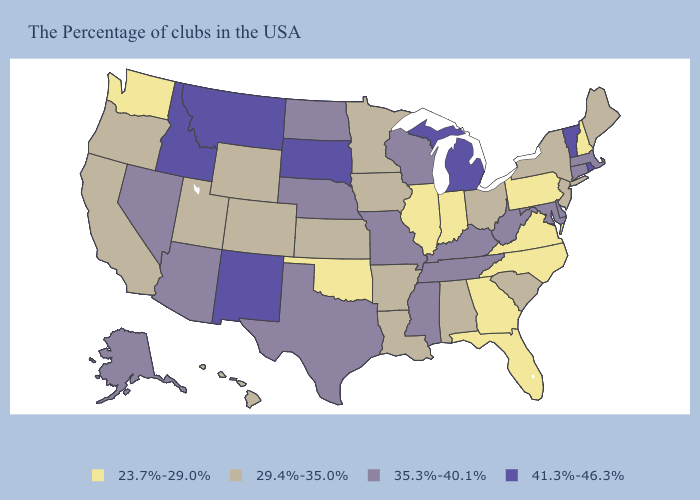Name the states that have a value in the range 35.3%-40.1%?
Concise answer only. Massachusetts, Connecticut, Delaware, Maryland, West Virginia, Kentucky, Tennessee, Wisconsin, Mississippi, Missouri, Nebraska, Texas, North Dakota, Arizona, Nevada, Alaska. What is the highest value in the USA?
Give a very brief answer. 41.3%-46.3%. Among the states that border Michigan , which have the lowest value?
Answer briefly. Indiana. Among the states that border Utah , which have the lowest value?
Answer briefly. Wyoming, Colorado. What is the lowest value in the MidWest?
Answer briefly. 23.7%-29.0%. What is the lowest value in the West?
Concise answer only. 23.7%-29.0%. What is the value of Nevada?
Write a very short answer. 35.3%-40.1%. What is the lowest value in the USA?
Answer briefly. 23.7%-29.0%. Among the states that border Arizona , does Nevada have the lowest value?
Quick response, please. No. How many symbols are there in the legend?
Short answer required. 4. What is the highest value in states that border Texas?
Short answer required. 41.3%-46.3%. Which states have the highest value in the USA?
Write a very short answer. Rhode Island, Vermont, Michigan, South Dakota, New Mexico, Montana, Idaho. Name the states that have a value in the range 23.7%-29.0%?
Keep it brief. New Hampshire, Pennsylvania, Virginia, North Carolina, Florida, Georgia, Indiana, Illinois, Oklahoma, Washington. Among the states that border Louisiana , does Arkansas have the highest value?
Concise answer only. No. What is the value of Michigan?
Be succinct. 41.3%-46.3%. 